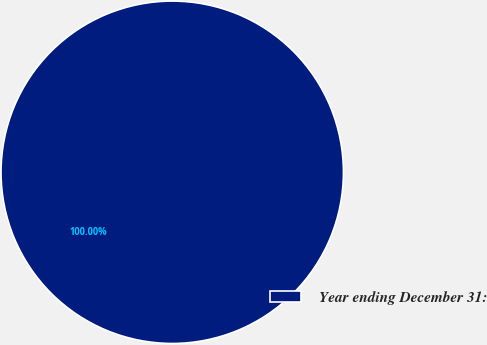<chart> <loc_0><loc_0><loc_500><loc_500><pie_chart><fcel>Year ending December 31:<nl><fcel>100.0%<nl></chart> 